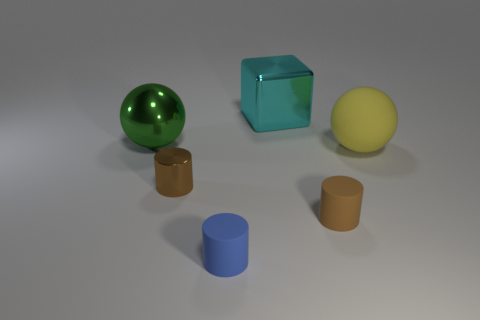Is there a thing of the same color as the cube?
Keep it short and to the point. No. There is another cylinder that is the same material as the blue cylinder; what is its size?
Give a very brief answer. Small. The big object behind the big ball behind the big sphere that is on the right side of the metallic cylinder is what shape?
Your answer should be very brief. Cube. There is another rubber object that is the same shape as the tiny blue thing; what size is it?
Offer a terse response. Small. What is the size of the thing that is both on the left side of the cyan metallic cube and behind the large rubber thing?
Your answer should be very brief. Large. What is the shape of the small rubber object that is the same color as the small shiny object?
Give a very brief answer. Cylinder. The metallic cylinder has what color?
Provide a succinct answer. Brown. There is a cylinder that is on the right side of the cyan cube; what size is it?
Provide a succinct answer. Small. There is a ball on the left side of the large sphere that is on the right side of the brown shiny cylinder; what number of metallic blocks are behind it?
Your answer should be compact. 1. The cylinder that is left of the rubber cylinder that is in front of the tiny brown matte cylinder is what color?
Your answer should be very brief. Brown. 